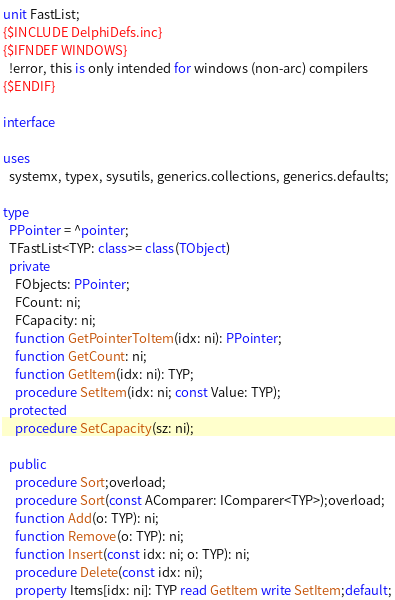Convert code to text. <code><loc_0><loc_0><loc_500><loc_500><_Pascal_>unit FastList;
{$INCLUDE DelphiDefs.inc}
{$IFNDEF WINDOWS}
  !error, this is only intended for windows (non-arc) compilers
{$ENDIF}

interface

uses
  systemx, typex, sysutils, generics.collections, generics.defaults;

type
  PPointer = ^pointer;
  TFastList<TYP: class>= class(TObject)
  private
    FObjects: PPointer;
    FCount: ni;
    FCapacity: ni;
    function GetPointerToItem(idx: ni): PPointer;
    function GetCount: ni;
    function GetItem(idx: ni): TYP;
    procedure SetItem(idx: ni; const Value: TYP);
  protected
    procedure SetCapacity(sz: ni);

  public
    procedure Sort;overload;
    procedure Sort(const AComparer: IComparer<TYP>);overload;
    function Add(o: TYP): ni;
    function Remove(o: TYP): ni;
    function Insert(const idx: ni; o: TYP): ni;
    procedure Delete(const idx: ni);
    property Items[idx: ni]: TYP read GetItem write SetItem;default;</code> 